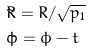Convert formula to latex. <formula><loc_0><loc_0><loc_500><loc_500>& \tilde { R } = R / \sqrt { p _ { 1 } } \\ & \tilde { \phi } = \phi - t</formula> 